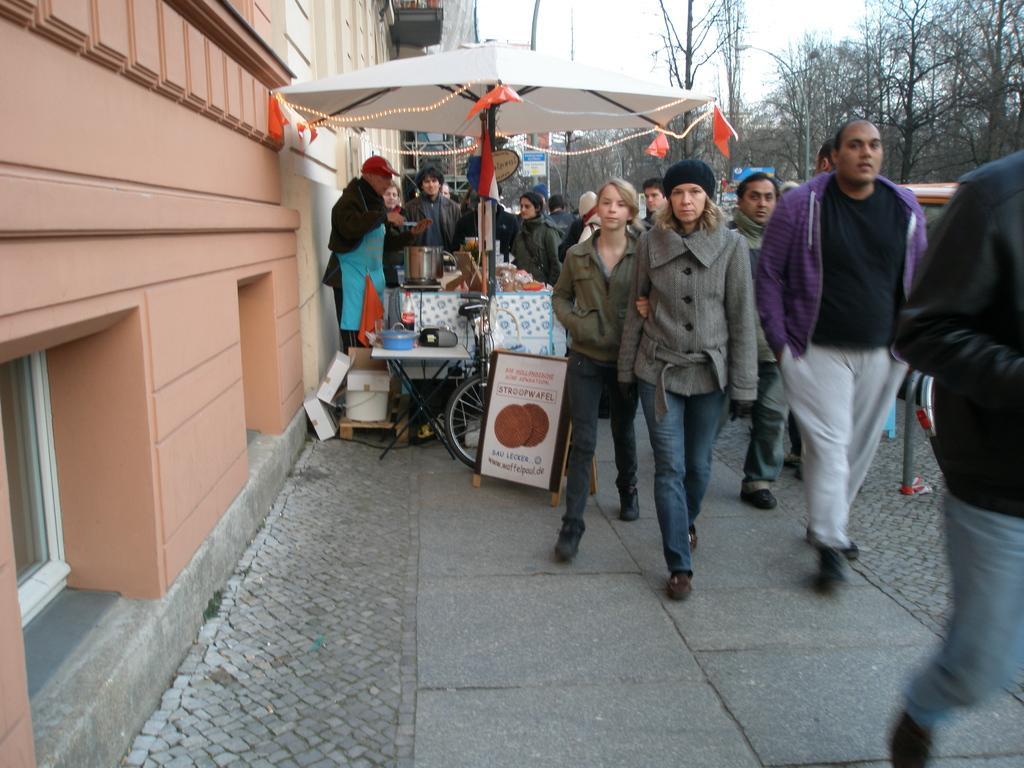Can you describe this image briefly? This picture describes about group of people, few are walking and few are standing, beside to them we can see an umbrella, under the umbrella we can find a bicycle, few tables and other things, and also we can see few trees, poles, sign boards and buildings. 